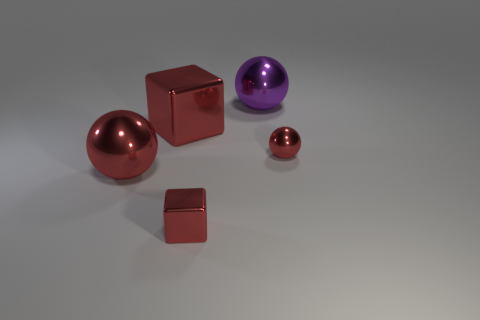What number of small metallic balls are behind the small red metallic cube in front of the big red shiny sphere? There is one small metallic ball positioned behind the small red metallic cube, which itself is located in front of the big red shiny sphere. 